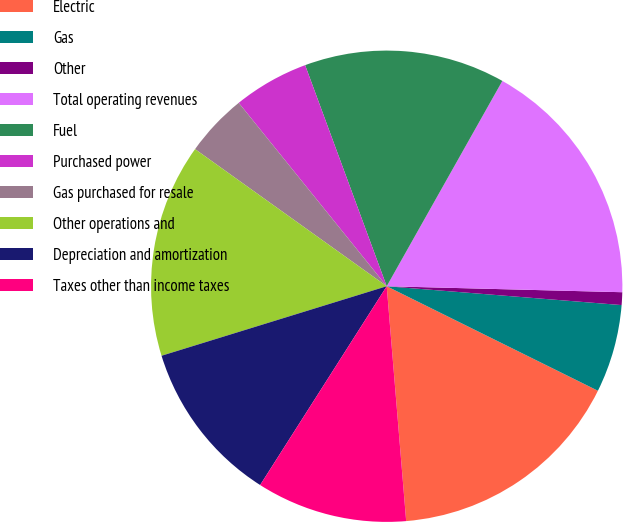<chart> <loc_0><loc_0><loc_500><loc_500><pie_chart><fcel>Electric<fcel>Gas<fcel>Other<fcel>Total operating revenues<fcel>Fuel<fcel>Purchased power<fcel>Gas purchased for resale<fcel>Other operations and<fcel>Depreciation and amortization<fcel>Taxes other than income taxes<nl><fcel>16.37%<fcel>6.04%<fcel>0.87%<fcel>17.24%<fcel>13.79%<fcel>5.18%<fcel>4.31%<fcel>14.65%<fcel>11.21%<fcel>10.34%<nl></chart> 